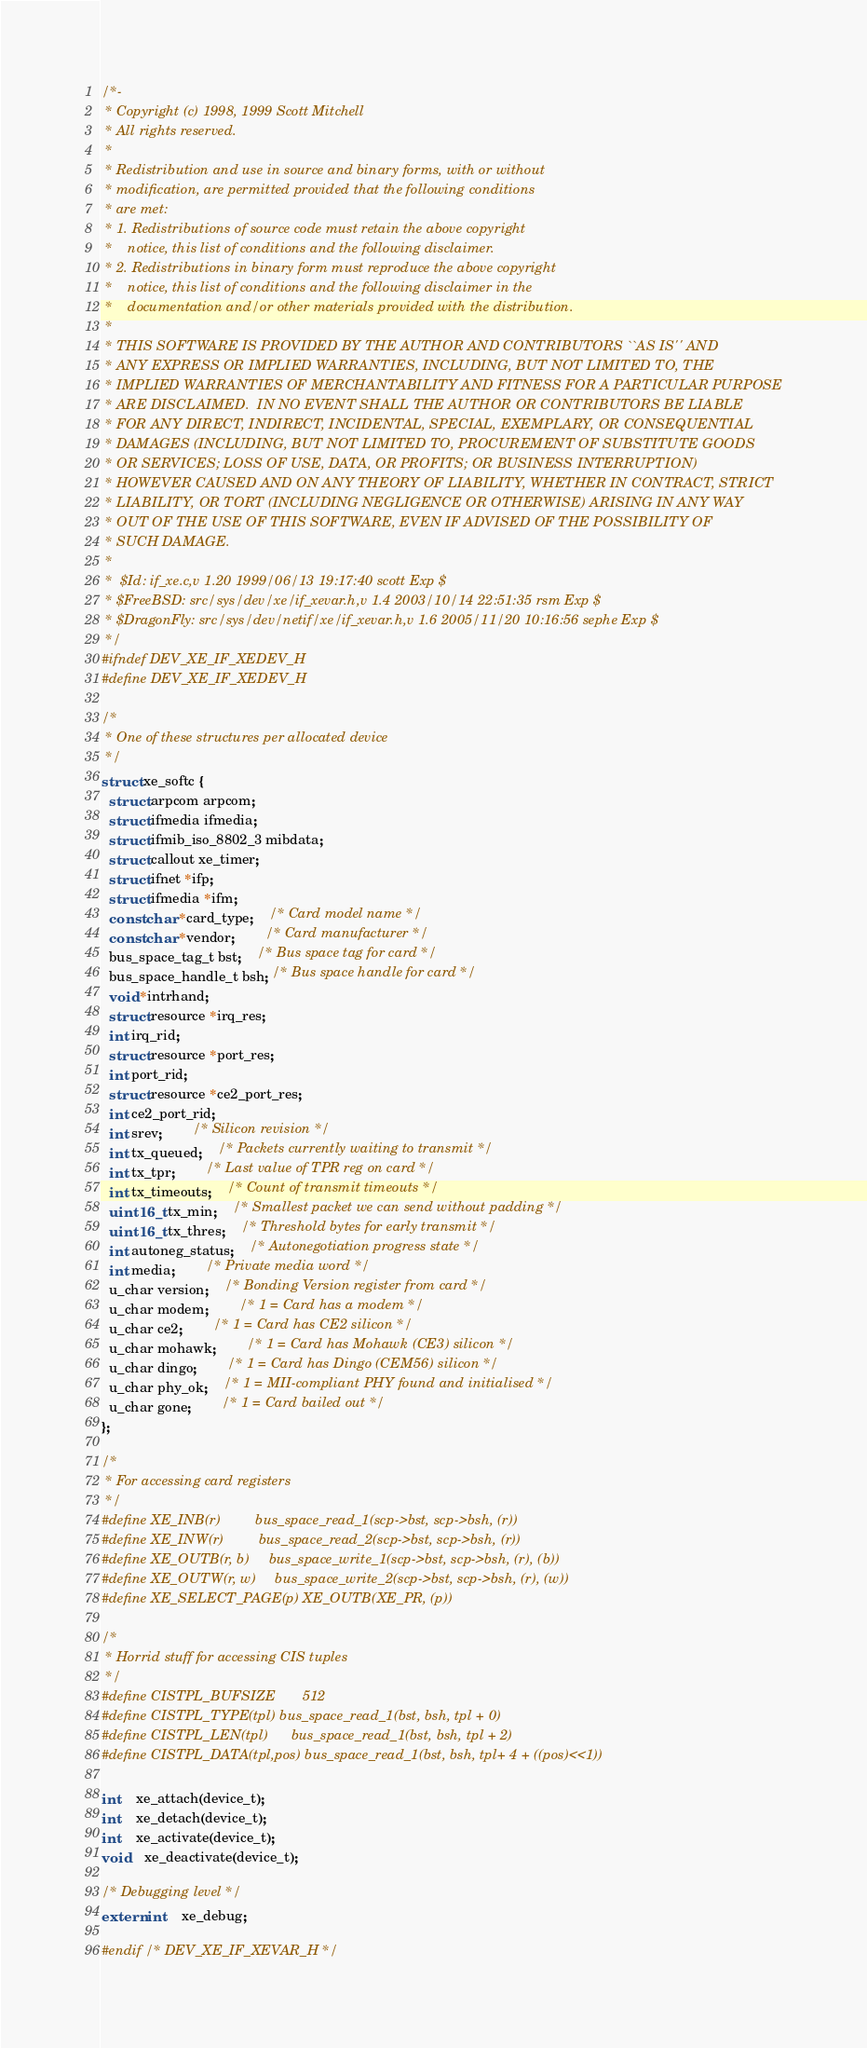Convert code to text. <code><loc_0><loc_0><loc_500><loc_500><_C_>/*-
 * Copyright (c) 1998, 1999 Scott Mitchell
 * All rights reserved.
 *
 * Redistribution and use in source and binary forms, with or without
 * modification, are permitted provided that the following conditions
 * are met:
 * 1. Redistributions of source code must retain the above copyright
 *    notice, this list of conditions and the following disclaimer.
 * 2. Redistributions in binary form must reproduce the above copyright
 *    notice, this list of conditions and the following disclaimer in the
 *    documentation and/or other materials provided with the distribution.
 *
 * THIS SOFTWARE IS PROVIDED BY THE AUTHOR AND CONTRIBUTORS ``AS IS'' AND
 * ANY EXPRESS OR IMPLIED WARRANTIES, INCLUDING, BUT NOT LIMITED TO, THE
 * IMPLIED WARRANTIES OF MERCHANTABILITY AND FITNESS FOR A PARTICULAR PURPOSE
 * ARE DISCLAIMED.  IN NO EVENT SHALL THE AUTHOR OR CONTRIBUTORS BE LIABLE
 * FOR ANY DIRECT, INDIRECT, INCIDENTAL, SPECIAL, EXEMPLARY, OR CONSEQUENTIAL
 * DAMAGES (INCLUDING, BUT NOT LIMITED TO, PROCUREMENT OF SUBSTITUTE GOODS
 * OR SERVICES; LOSS OF USE, DATA, OR PROFITS; OR BUSINESS INTERRUPTION)
 * HOWEVER CAUSED AND ON ANY THEORY OF LIABILITY, WHETHER IN CONTRACT, STRICT
 * LIABILITY, OR TORT (INCLUDING NEGLIGENCE OR OTHERWISE) ARISING IN ANY WAY
 * OUT OF THE USE OF THIS SOFTWARE, EVEN IF ADVISED OF THE POSSIBILITY OF
 * SUCH DAMAGE.
 *
 *	$Id: if_xe.c,v 1.20 1999/06/13 19:17:40 scott Exp $
 * $FreeBSD: src/sys/dev/xe/if_xevar.h,v 1.4 2003/10/14 22:51:35 rsm Exp $
 * $DragonFly: src/sys/dev/netif/xe/if_xevar.h,v 1.6 2005/11/20 10:16:56 sephe Exp $
 */
#ifndef DEV_XE_IF_XEDEV_H
#define DEV_XE_IF_XEDEV_H

/*
 * One of these structures per allocated device
 */
struct xe_softc {
  struct arpcom arpcom;
  struct ifmedia ifmedia;
  struct ifmib_iso_8802_3 mibdata;
  struct callout xe_timer;
  struct ifnet *ifp;
  struct ifmedia *ifm;
  const char *card_type;	/* Card model name */
  const char *vendor;		/* Card manufacturer */
  bus_space_tag_t bst;	/* Bus space tag for card */
  bus_space_handle_t bsh; /* Bus space handle for card */
  void *intrhand;
  struct resource *irq_res;
  int irq_rid;
  struct resource *port_res;
  int port_rid;
  struct resource *ce2_port_res;
  int ce2_port_rid;
  int srev;     	/* Silicon revision */
  int tx_queued;	/* Packets currently waiting to transmit */
  int tx_tpr;		/* Last value of TPR reg on card */
  int tx_timeouts;	/* Count of transmit timeouts */
  uint16_t tx_min;	/* Smallest packet we can send without padding */
  uint16_t tx_thres;	/* Threshold bytes for early transmit */
  int autoneg_status;	/* Autonegotiation progress state */
  int media;		/* Private media word */
  u_char version;	/* Bonding Version register from card */
  u_char modem;		/* 1 = Card has a modem */
  u_char ce2;		/* 1 = Card has CE2 silicon */
  u_char mohawk;      	/* 1 = Card has Mohawk (CE3) silicon */
  u_char dingo;    	/* 1 = Card has Dingo (CEM56) silicon */
  u_char phy_ok;	/* 1 = MII-compliant PHY found and initialised */
  u_char gone;		/* 1 = Card bailed out */
};

/*
 * For accessing card registers
 */
#define XE_INB(r)         bus_space_read_1(scp->bst, scp->bsh, (r))
#define XE_INW(r)         bus_space_read_2(scp->bst, scp->bsh, (r))
#define XE_OUTB(r, b)     bus_space_write_1(scp->bst, scp->bsh, (r), (b))
#define XE_OUTW(r, w)     bus_space_write_2(scp->bst, scp->bsh, (r), (w))
#define XE_SELECT_PAGE(p) XE_OUTB(XE_PR, (p))

/*
 * Horrid stuff for accessing CIS tuples
 */
#define CISTPL_BUFSIZE		512
#define CISTPL_TYPE(tpl)	bus_space_read_1(bst, bsh, tpl + 0)
#define CISTPL_LEN(tpl)		bus_space_read_1(bst, bsh, tpl + 2)
#define CISTPL_DATA(tpl,pos)	bus_space_read_1(bst, bsh, tpl+ 4 + ((pos)<<1))

int	xe_attach(device_t);
int	xe_detach(device_t);
int	xe_activate(device_t);
void	xe_deactivate(device_t);

/* Debugging level */
extern int	xe_debug;

#endif /* DEV_XE_IF_XEVAR_H */
</code> 